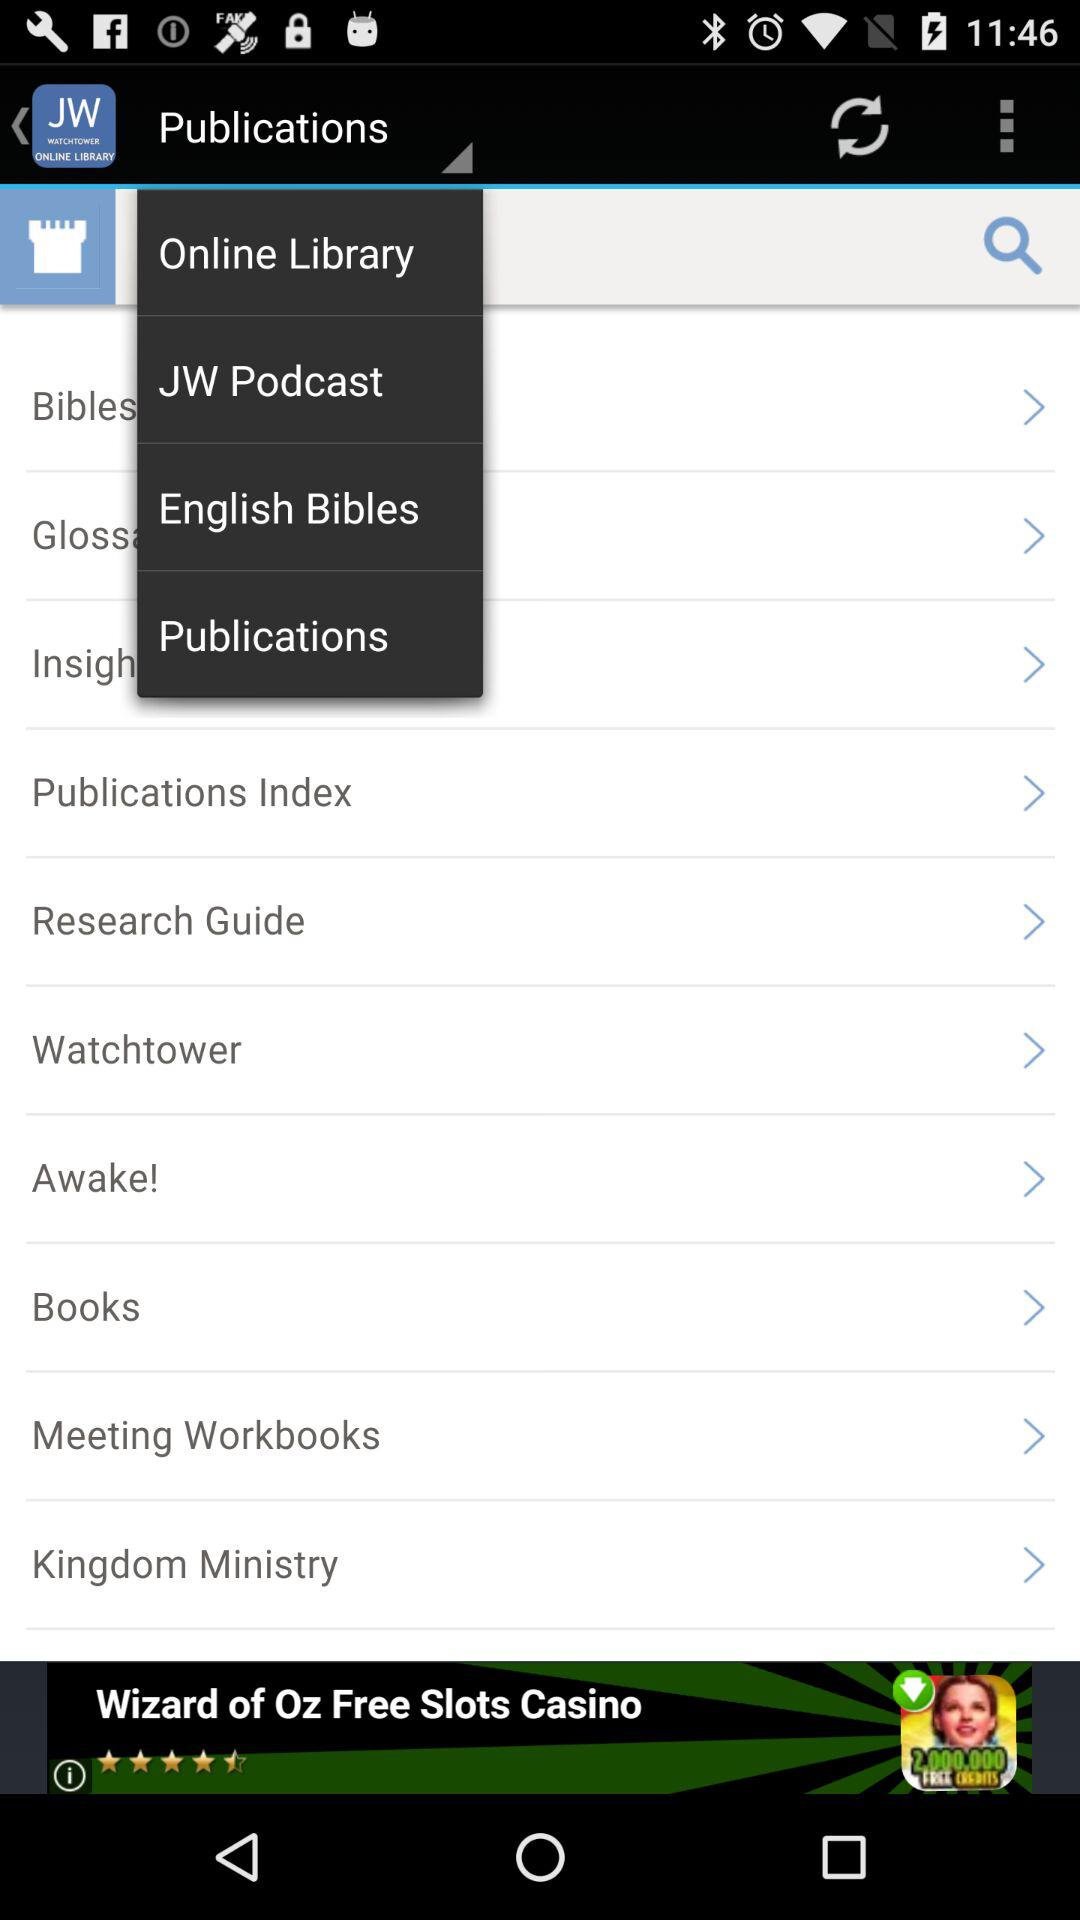Which option is selected? The selected option is "Publications". 